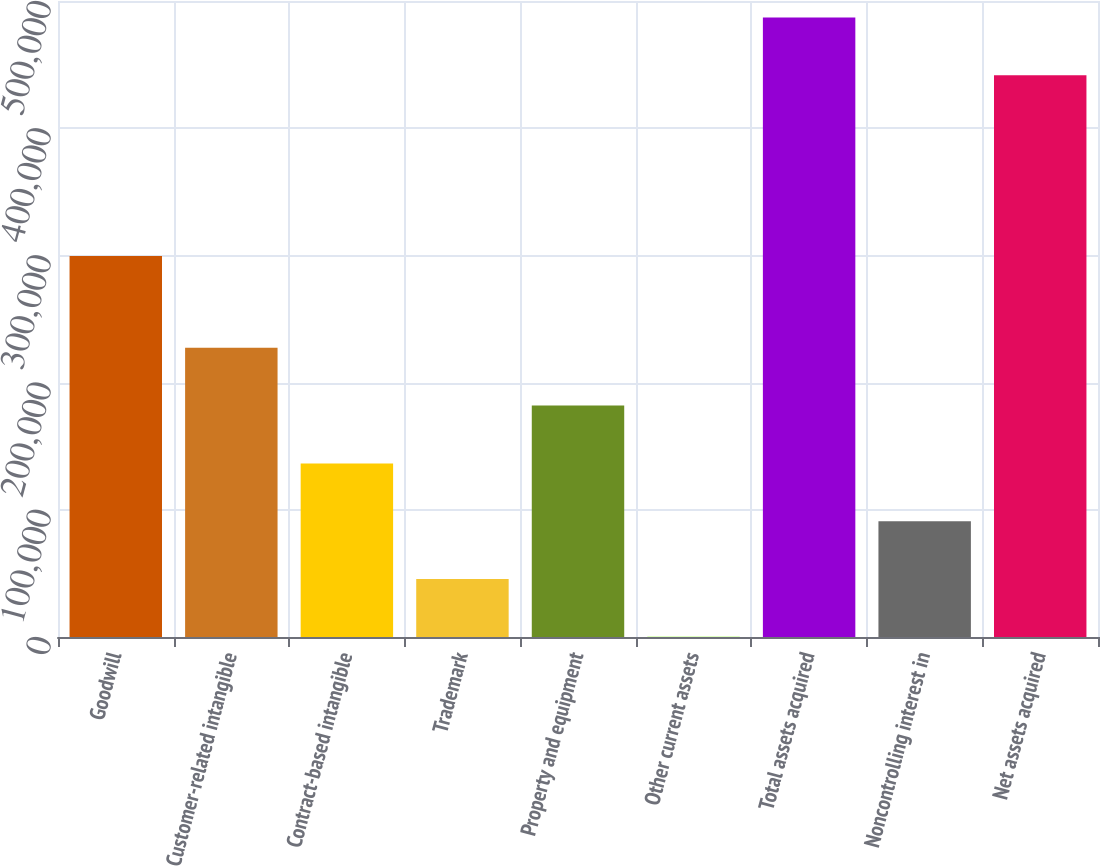<chart> <loc_0><loc_0><loc_500><loc_500><bar_chart><fcel>Goodwill<fcel>Customer-related intangible<fcel>Contract-based intangible<fcel>Trademark<fcel>Property and equipment<fcel>Other current assets<fcel>Total assets acquired<fcel>Noncontrolling interest in<fcel>Net assets acquired<nl><fcel>299474<fcel>227380<fcel>136473<fcel>45565.6<fcel>181926<fcel>112<fcel>487088<fcel>91019.2<fcel>441634<nl></chart> 